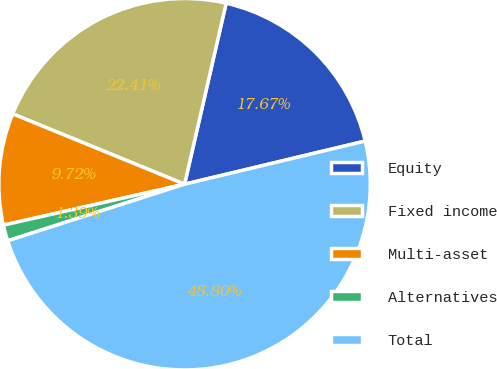<chart> <loc_0><loc_0><loc_500><loc_500><pie_chart><fcel>Equity<fcel>Fixed income<fcel>Multi-asset<fcel>Alternatives<fcel>Total<nl><fcel>17.67%<fcel>22.41%<fcel>9.72%<fcel>1.39%<fcel>48.8%<nl></chart> 